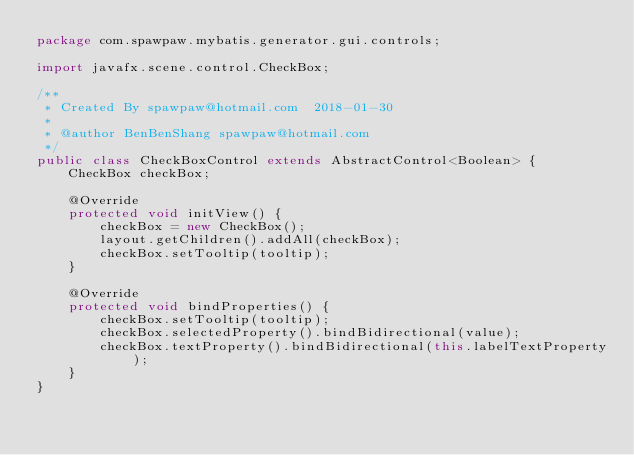Convert code to text. <code><loc_0><loc_0><loc_500><loc_500><_Java_>package com.spawpaw.mybatis.generator.gui.controls;

import javafx.scene.control.CheckBox;

/**
 * Created By spawpaw@hotmail.com  2018-01-30
 *
 * @author BenBenShang spawpaw@hotmail.com
 */
public class CheckBoxControl extends AbstractControl<Boolean> {
    CheckBox checkBox;

    @Override
    protected void initView() {
        checkBox = new CheckBox();
        layout.getChildren().addAll(checkBox);
        checkBox.setTooltip(tooltip);
    }

    @Override
    protected void bindProperties() {
        checkBox.setTooltip(tooltip);
        checkBox.selectedProperty().bindBidirectional(value);
        checkBox.textProperty().bindBidirectional(this.labelTextProperty);
    }
}
</code> 